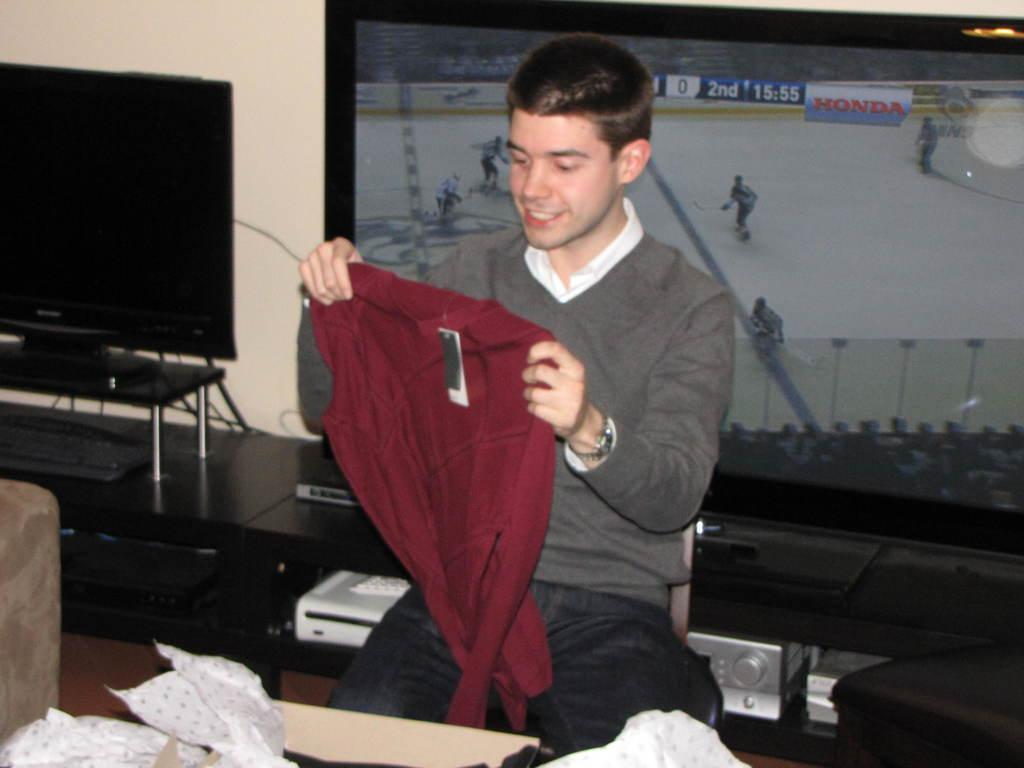<image>
Present a compact description of the photo's key features. A boys opens a gift in front of a TV with a game playing the 2nd 15:55. 